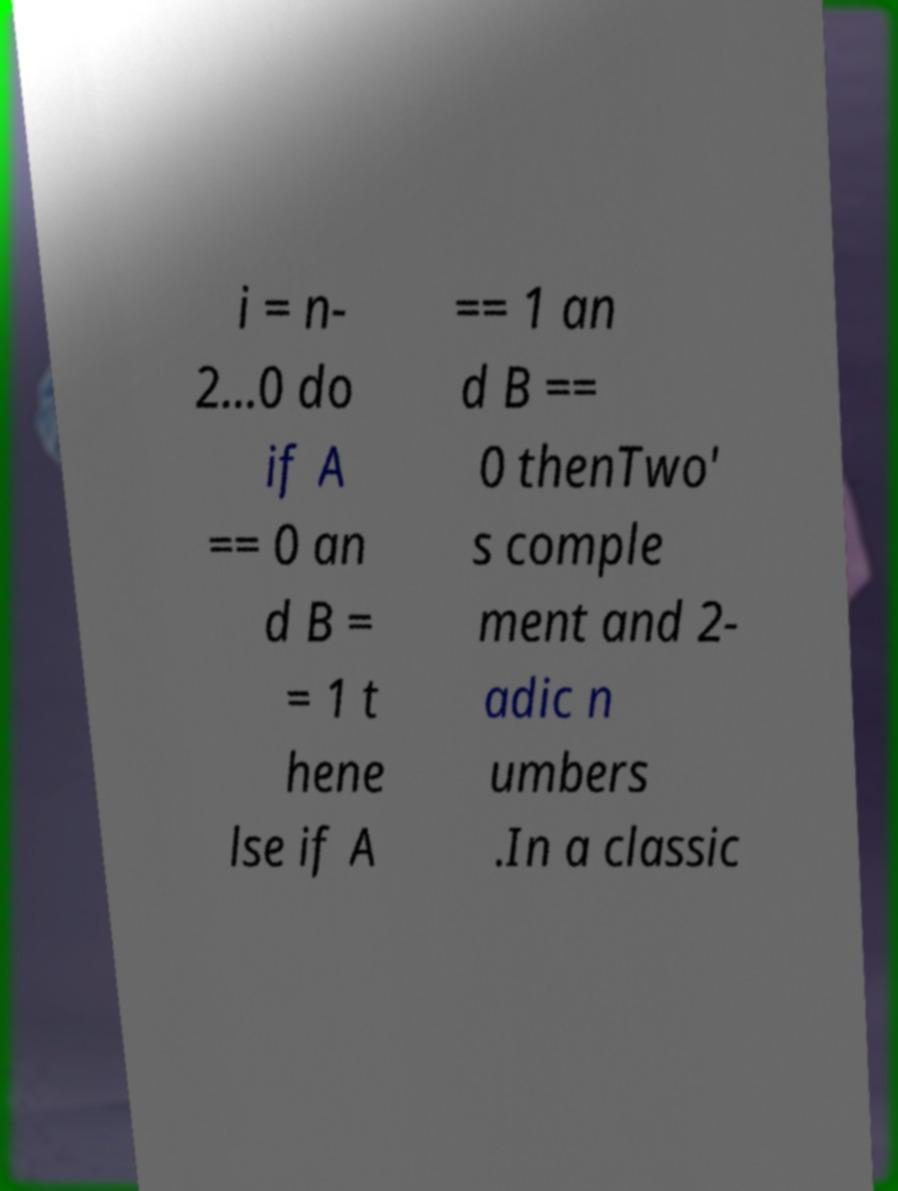Can you read and provide the text displayed in the image?This photo seems to have some interesting text. Can you extract and type it out for me? i = n- 2...0 do if A == 0 an d B = = 1 t hene lse if A == 1 an d B == 0 thenTwo' s comple ment and 2- adic n umbers .In a classic 